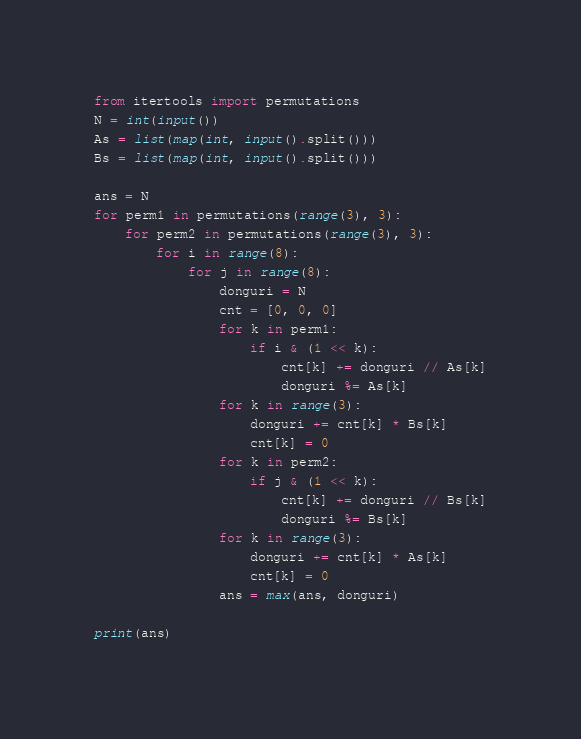Convert code to text. <code><loc_0><loc_0><loc_500><loc_500><_Python_>from itertools import permutations
N = int(input())
As = list(map(int, input().split()))
Bs = list(map(int, input().split()))

ans = N
for perm1 in permutations(range(3), 3):
    for perm2 in permutations(range(3), 3):
        for i in range(8):
            for j in range(8):
                donguri = N
                cnt = [0, 0, 0]
                for k in perm1:
                    if i & (1 << k):
                        cnt[k] += donguri // As[k]
                        donguri %= As[k]
                for k in range(3):
                    donguri += cnt[k] * Bs[k]
                    cnt[k] = 0
                for k in perm2:
                    if j & (1 << k):
                        cnt[k] += donguri // Bs[k]
                        donguri %= Bs[k]
                for k in range(3):
                    donguri += cnt[k] * As[k]
                    cnt[k] = 0
                ans = max(ans, donguri)
                
print(ans)</code> 